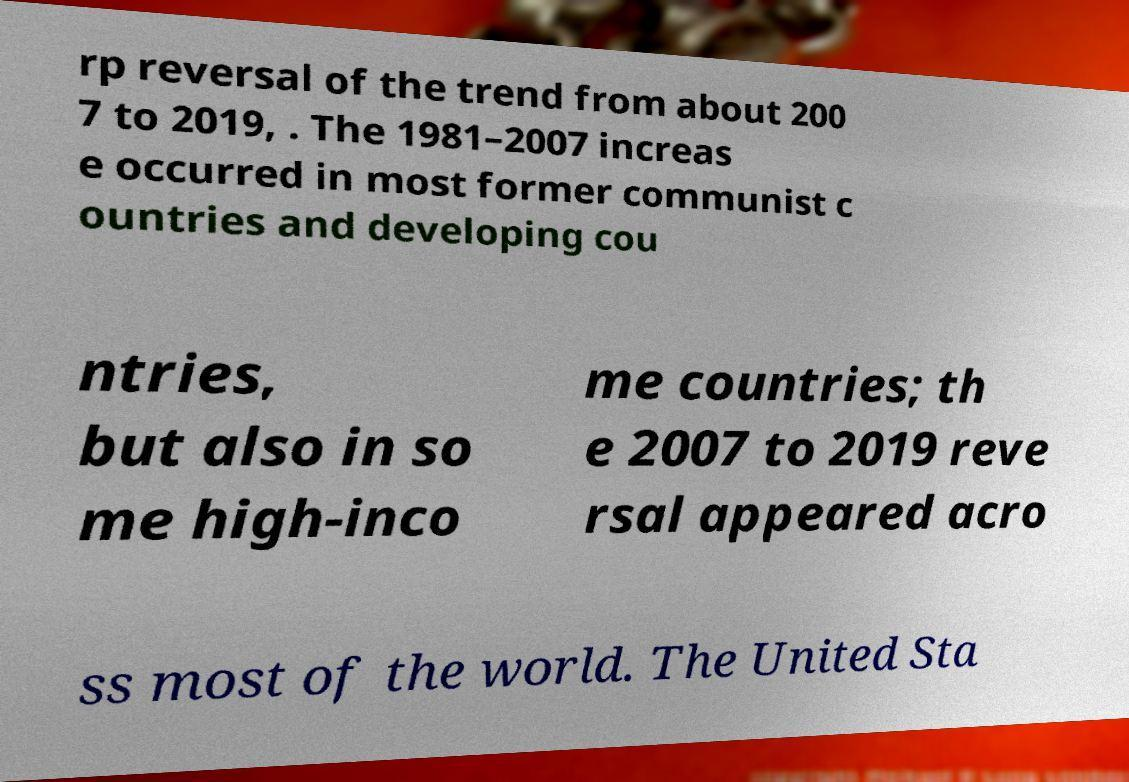Could you extract and type out the text from this image? rp reversal of the trend from about 200 7 to 2019, . The 1981–2007 increas e occurred in most former communist c ountries and developing cou ntries, but also in so me high-inco me countries; th e 2007 to 2019 reve rsal appeared acro ss most of the world. The United Sta 